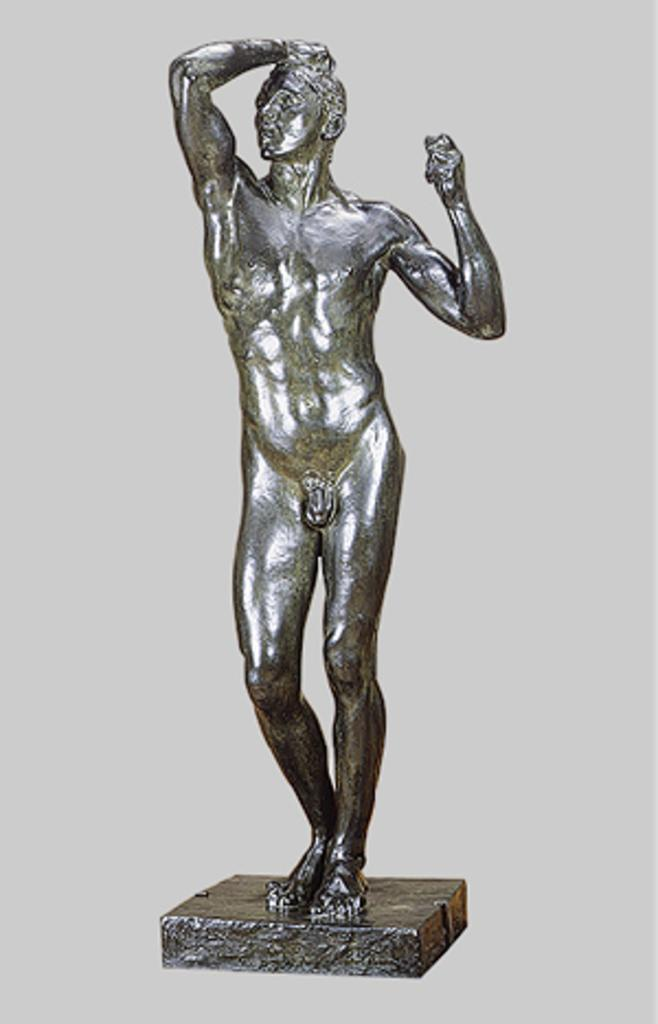What is the main subject of the image? There is a statue in the image. What letters are being delivered to the statue in the image? There are no letters or any indication of delivery in the image; it only features a statue. 